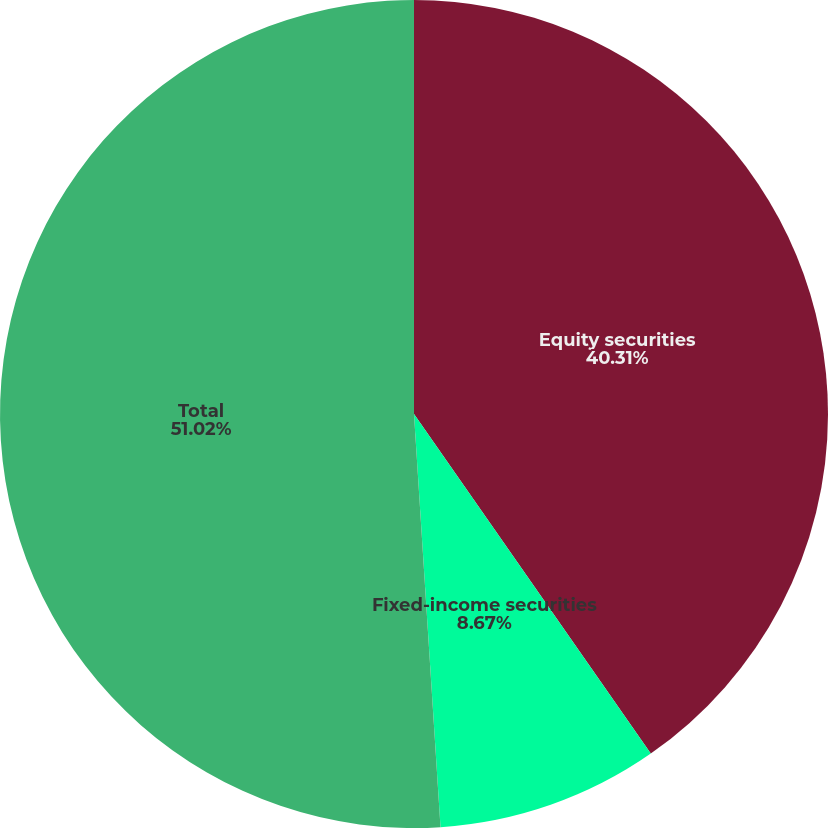Convert chart to OTSL. <chart><loc_0><loc_0><loc_500><loc_500><pie_chart><fcel>Equity securities<fcel>Fixed-income securities<fcel>Total<nl><fcel>40.31%<fcel>8.67%<fcel>51.02%<nl></chart> 